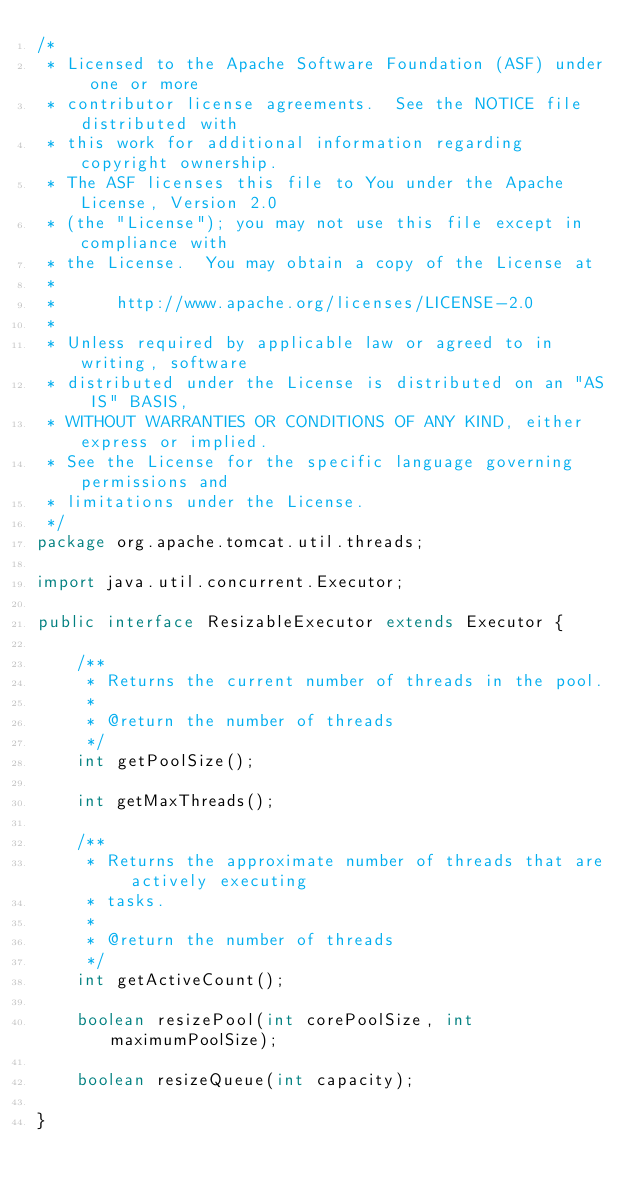Convert code to text. <code><loc_0><loc_0><loc_500><loc_500><_Java_>/*
 * Licensed to the Apache Software Foundation (ASF) under one or more
 * contributor license agreements.  See the NOTICE file distributed with
 * this work for additional information regarding copyright ownership.
 * The ASF licenses this file to You under the Apache License, Version 2.0
 * (the "License"); you may not use this file except in compliance with
 * the License.  You may obtain a copy of the License at
 *
 *      http://www.apache.org/licenses/LICENSE-2.0
 *
 * Unless required by applicable law or agreed to in writing, software
 * distributed under the License is distributed on an "AS IS" BASIS,
 * WITHOUT WARRANTIES OR CONDITIONS OF ANY KIND, either express or implied.
 * See the License for the specific language governing permissions and
 * limitations under the License.
 */
package org.apache.tomcat.util.threads;

import java.util.concurrent.Executor;

public interface ResizableExecutor extends Executor {

    /**
     * Returns the current number of threads in the pool.
     *
     * @return the number of threads
     */
    int getPoolSize();

    int getMaxThreads();

    /**
     * Returns the approximate number of threads that are actively executing
     * tasks.
     *
     * @return the number of threads
     */
    int getActiveCount();

    boolean resizePool(int corePoolSize, int maximumPoolSize);

    boolean resizeQueue(int capacity);

}
</code> 